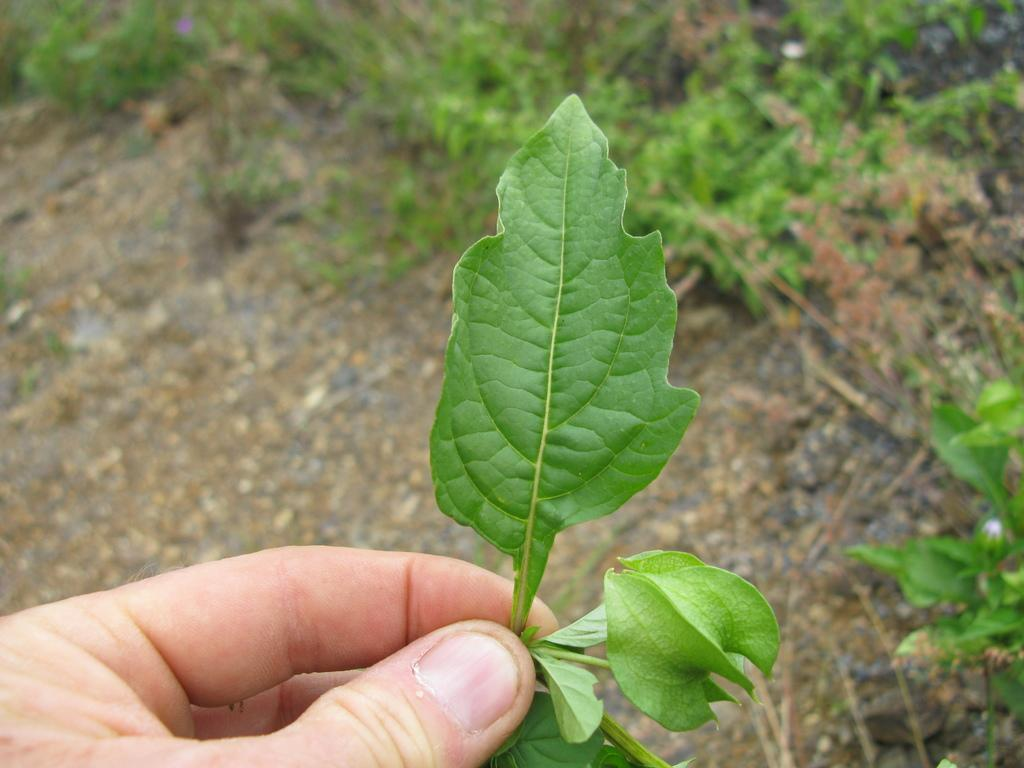What is the main subject of the image? The main subject of the image is a leaf. Where is the leaf located in the image? The leaf is in a human hand in the image. What can be seen in the background of the image? There is grass and the ground visible in the background of the image. What type of bridge can be seen in the background of the image? There is no bridge present in the image; it only features a leaf in a human hand and grass in the background. 